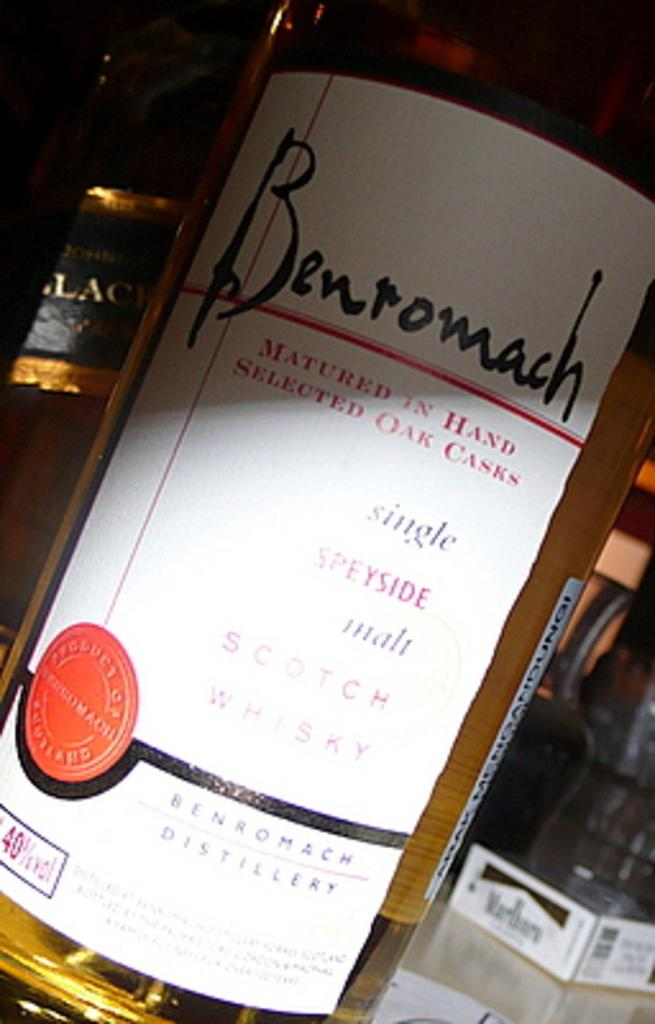<image>
Describe the image concisely. Benromach Distillery shows off their single Speyside malt Scotch Whiskey. 